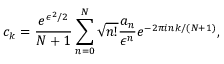Convert formula to latex. <formula><loc_0><loc_0><loc_500><loc_500>c _ { k } = \frac { e ^ { \epsilon ^ { 2 } / 2 } } { N + 1 } \sum _ { n = 0 } ^ { N } \sqrt { n ! } \frac { a _ { n } } { \epsilon ^ { n } } e ^ { - 2 \pi i n k / ( N + 1 ) } ,</formula> 